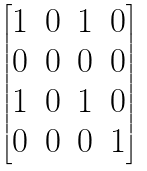<formula> <loc_0><loc_0><loc_500><loc_500>\begin{bmatrix} 1 & 0 & 1 & 0 \\ 0 & 0 & 0 & 0 \\ 1 & 0 & 1 & 0 \\ 0 & 0 & 0 & 1 \end{bmatrix}</formula> 